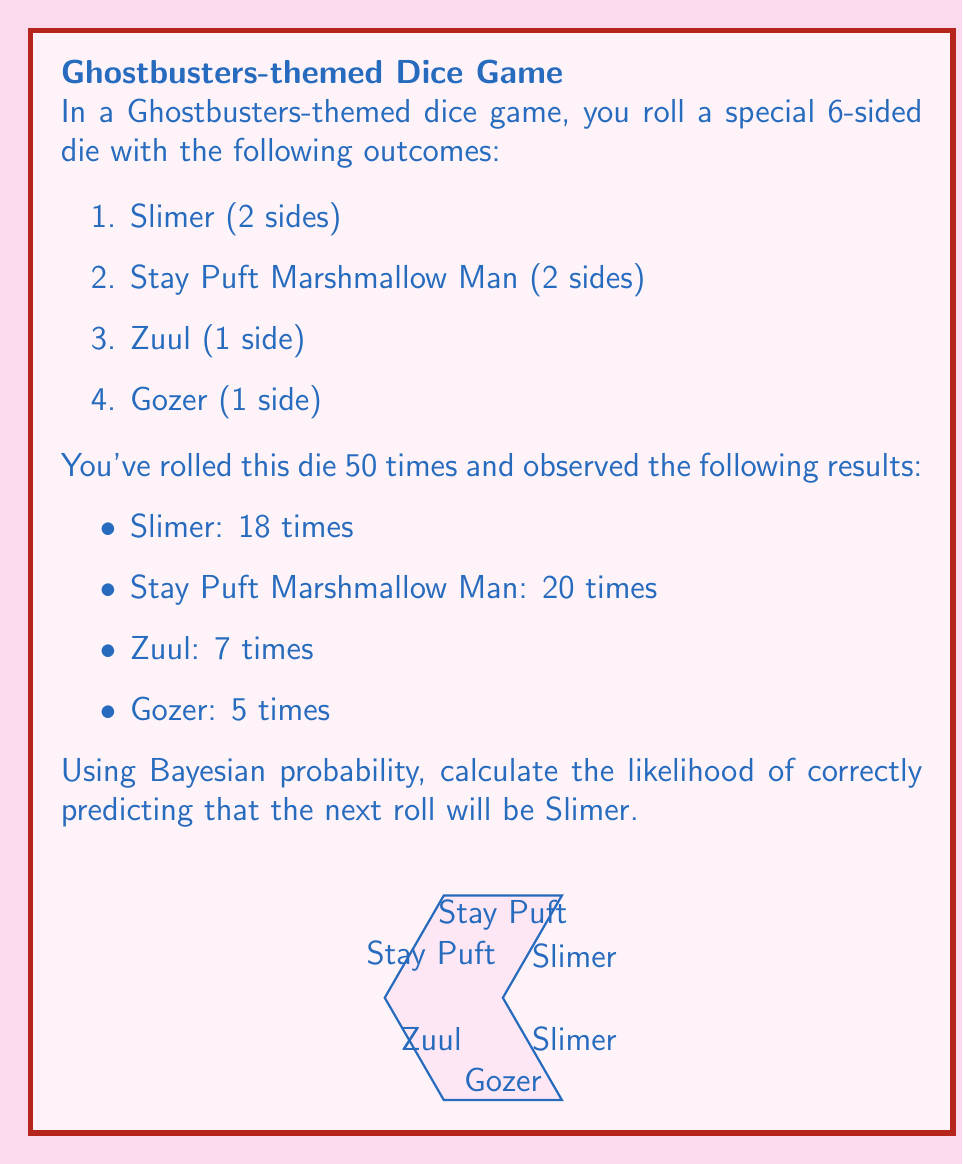What is the answer to this math problem? To solve this problem using Bayesian probability, we'll follow these steps:

1. Calculate the prior probability of rolling Slimer based on the die's composition:
   $P(Slimer) = \frac{2}{6} = \frac{1}{3}$

2. Calculate the likelihood of observing our data given that the true probability is $\frac{1}{3}$:
   $P(Data|Slimer) = \binom{50}{18} (\frac{1}{3})^{18} (\frac{2}{3})^{32}$

3. Calculate the marginal likelihood (probability of observing our data):
   $P(Data) = \binom{50}{18} (\frac{1}{3})^{18} (\frac{2}{3})^{32} + \binom{50}{20} (\frac{1}{3})^{20} (\frac{2}{3})^{30} + \binom{50}{7} (\frac{1}{6})^7 (\frac{5}{6})^{43} + \binom{50}{5} (\frac{1}{6})^5 (\frac{5}{6})^{45}$

4. Apply Bayes' theorem to calculate the posterior probability:
   $$P(Slimer|Data) = \frac{P(Data|Slimer) \cdot P(Slimer)}{P(Data)}$$

   $$P(Slimer|Data) = \frac{\binom{50}{18} (\frac{1}{3})^{18} (\frac{2}{3})^{32} \cdot \frac{1}{3}}{\binom{50}{18} (\frac{1}{3})^{18} (\frac{2}{3})^{32} + \binom{50}{20} (\frac{1}{3})^{20} (\frac{2}{3})^{30} + \binom{50}{7} (\frac{1}{6})^7 (\frac{5}{6})^{43} + \binom{50}{5} (\frac{1}{6})^5 (\frac{5}{6})^{45}}$$

5. Simplify and calculate the final result:
   $P(Slimer|Data) \approx 0.3600$

This means that based on the observed data and our prior knowledge of the die, there is approximately a 36% chance of correctly predicting that the next roll will be Slimer.
Answer: $P(Slimer|Data) \approx 0.3600$ or 36% 